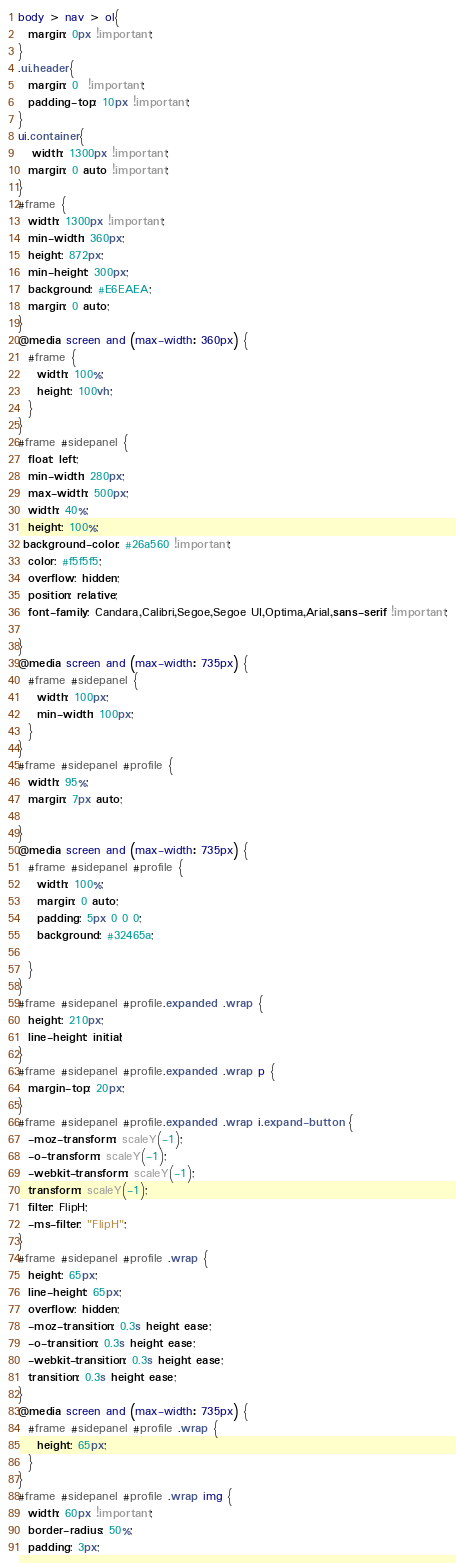Convert code to text. <code><loc_0><loc_0><loc_500><loc_500><_CSS_>body > nav > ol{
  margin: 0px !important;
}
.ui.header{
  margin: 0  !important;
  padding-top: 10px !important;
}
ui.container{
   width: 1300px !important;
  margin: 0 auto !important;
}
#frame {
  width: 1300px !important;
  min-width: 360px;
  height: 872px;
  min-height: 300px;
  background: #E6EAEA;
  margin: 0 auto;
}
@media screen and (max-width: 360px) {
  #frame {
    width: 100%;
    height: 100vh;
  }
}
#frame #sidepanel {
  float: left;
  min-width: 280px;
  max-width: 500px;
  width: 40%;
  height: 100%;
 background-color: #26a560 !important;
  color: #f5f5f5;
  overflow: hidden;
  position: relative;
  font-family: Candara,Calibri,Segoe,Segoe UI,Optima,Arial,sans-serif !important;

}
@media screen and (max-width: 735px) {
  #frame #sidepanel {
    width: 100px;
    min-width: 100px;
  }
}
#frame #sidepanel #profile {
  width: 95%;
  margin: 7px auto;

}
@media screen and (max-width: 735px) {
  #frame #sidepanel #profile {
    width: 100%;
    margin: 0 auto;
    padding: 5px 0 0 0;
    background: #32465a;

  }
}
#frame #sidepanel #profile.expanded .wrap {
  height: 210px;
  line-height: initial;
}
#frame #sidepanel #profile.expanded .wrap p {
  margin-top: 20px;
}
#frame #sidepanel #profile.expanded .wrap i.expand-button {
  -moz-transform: scaleY(-1);
  -o-transform: scaleY(-1);
  -webkit-transform: scaleY(-1);
  transform: scaleY(-1);
  filter: FlipH;
  -ms-filter: "FlipH";
}
#frame #sidepanel #profile .wrap {
  height: 65px;
  line-height: 65px;
  overflow: hidden;
  -moz-transition: 0.3s height ease;
  -o-transition: 0.3s height ease;
  -webkit-transition: 0.3s height ease;
  transition: 0.3s height ease;
}
@media screen and (max-width: 735px) {
  #frame #sidepanel #profile .wrap {
    height: 65px;
  }
}
#frame #sidepanel #profile .wrap img {
  width: 60px !important;
  border-radius: 50%;
  padding: 3px;</code> 